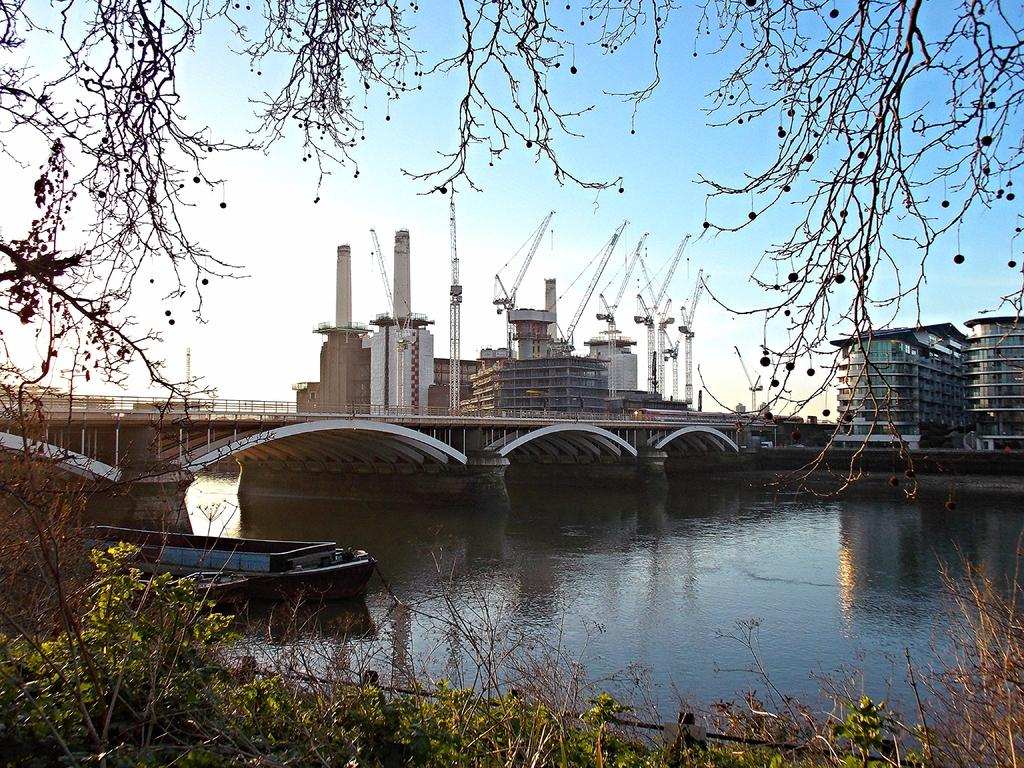What types of vegetation can be seen in the foreground of the image? There are plants and trees in the foreground of the image. What structures can be seen in the background of the image? There is a boat, a bridge, buildings, and cranes in the background of the image. What part of the natural environment is visible in the background of the image? The sky is visible in the background of the image. Can you tell me how many deer are visible in the image? There are no deer present in the image. What level of experience is required to operate the cranes in the image? The image does not provide information about the level of experience required to operate the cranes. 